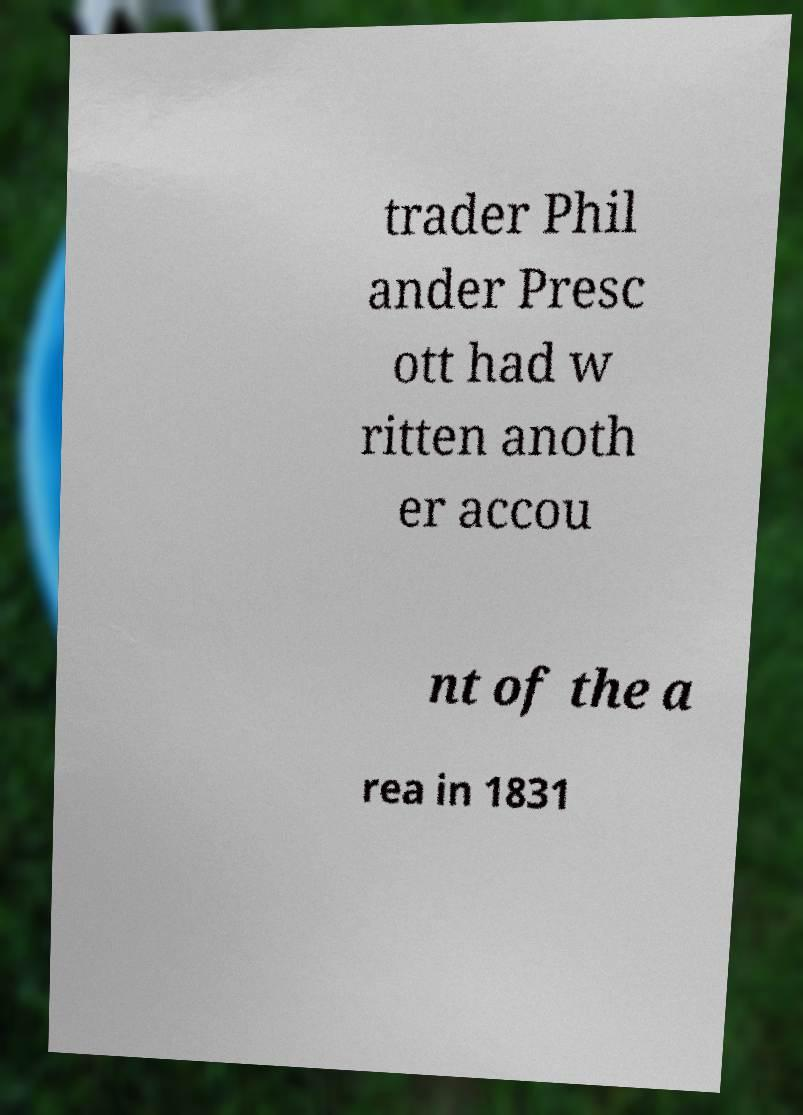For documentation purposes, I need the text within this image transcribed. Could you provide that? trader Phil ander Presc ott had w ritten anoth er accou nt of the a rea in 1831 